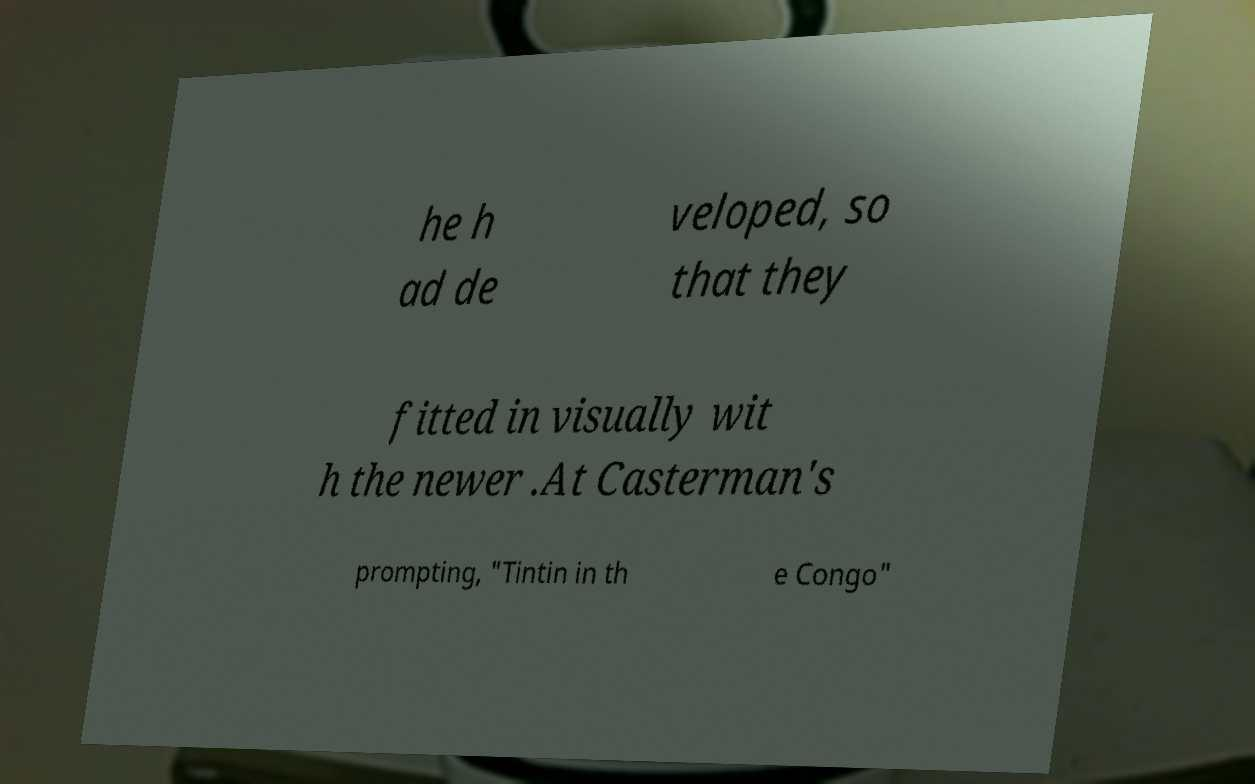Please identify and transcribe the text found in this image. he h ad de veloped, so that they fitted in visually wit h the newer .At Casterman's prompting, "Tintin in th e Congo" 